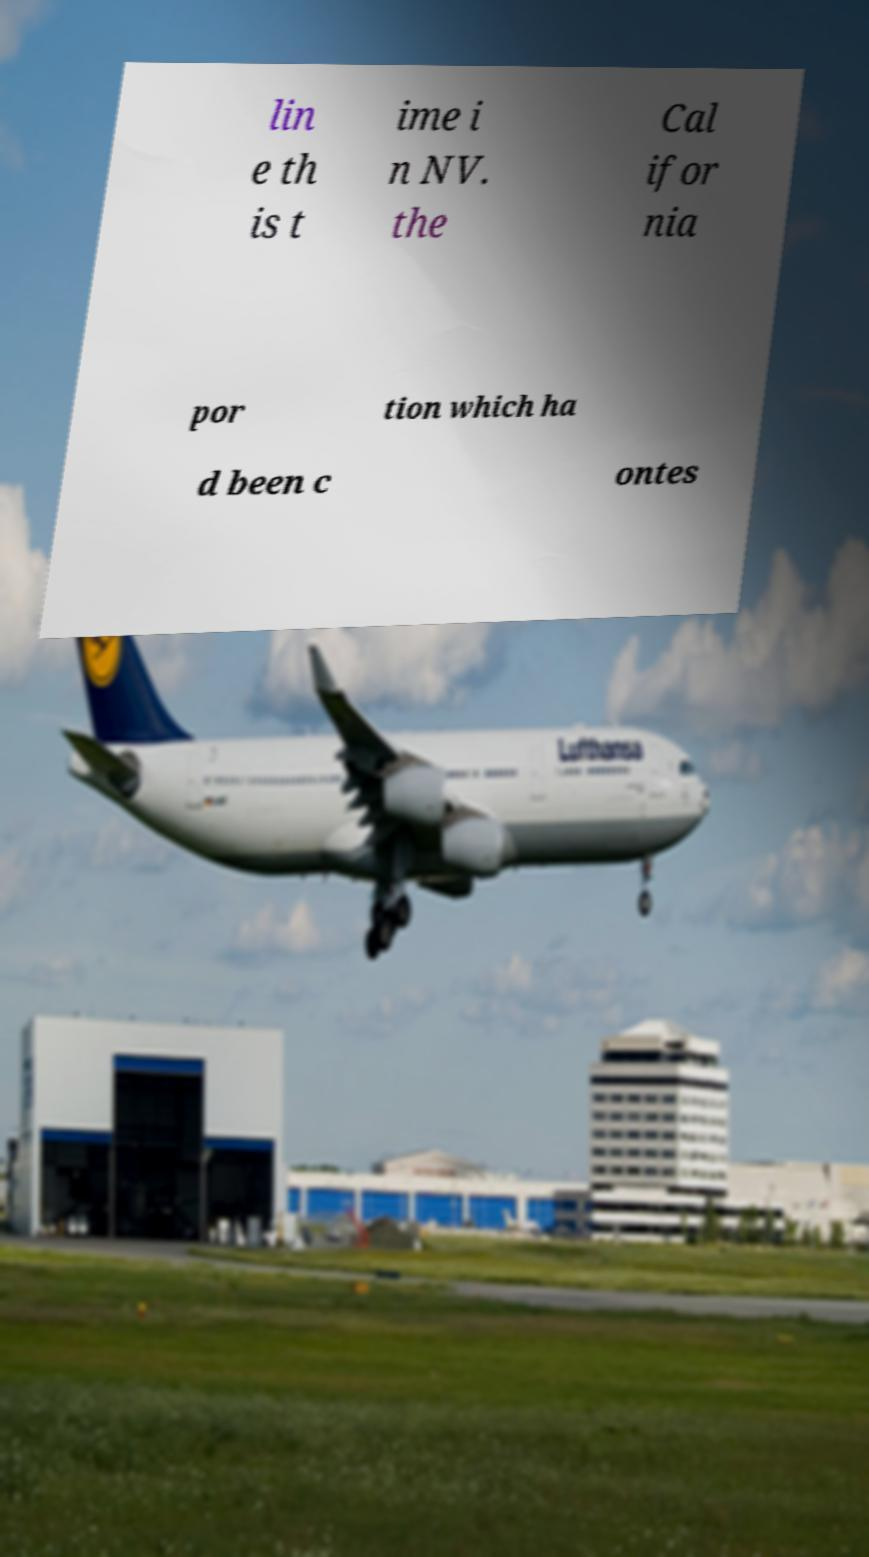For documentation purposes, I need the text within this image transcribed. Could you provide that? lin e th is t ime i n NV. the Cal ifor nia por tion which ha d been c ontes 